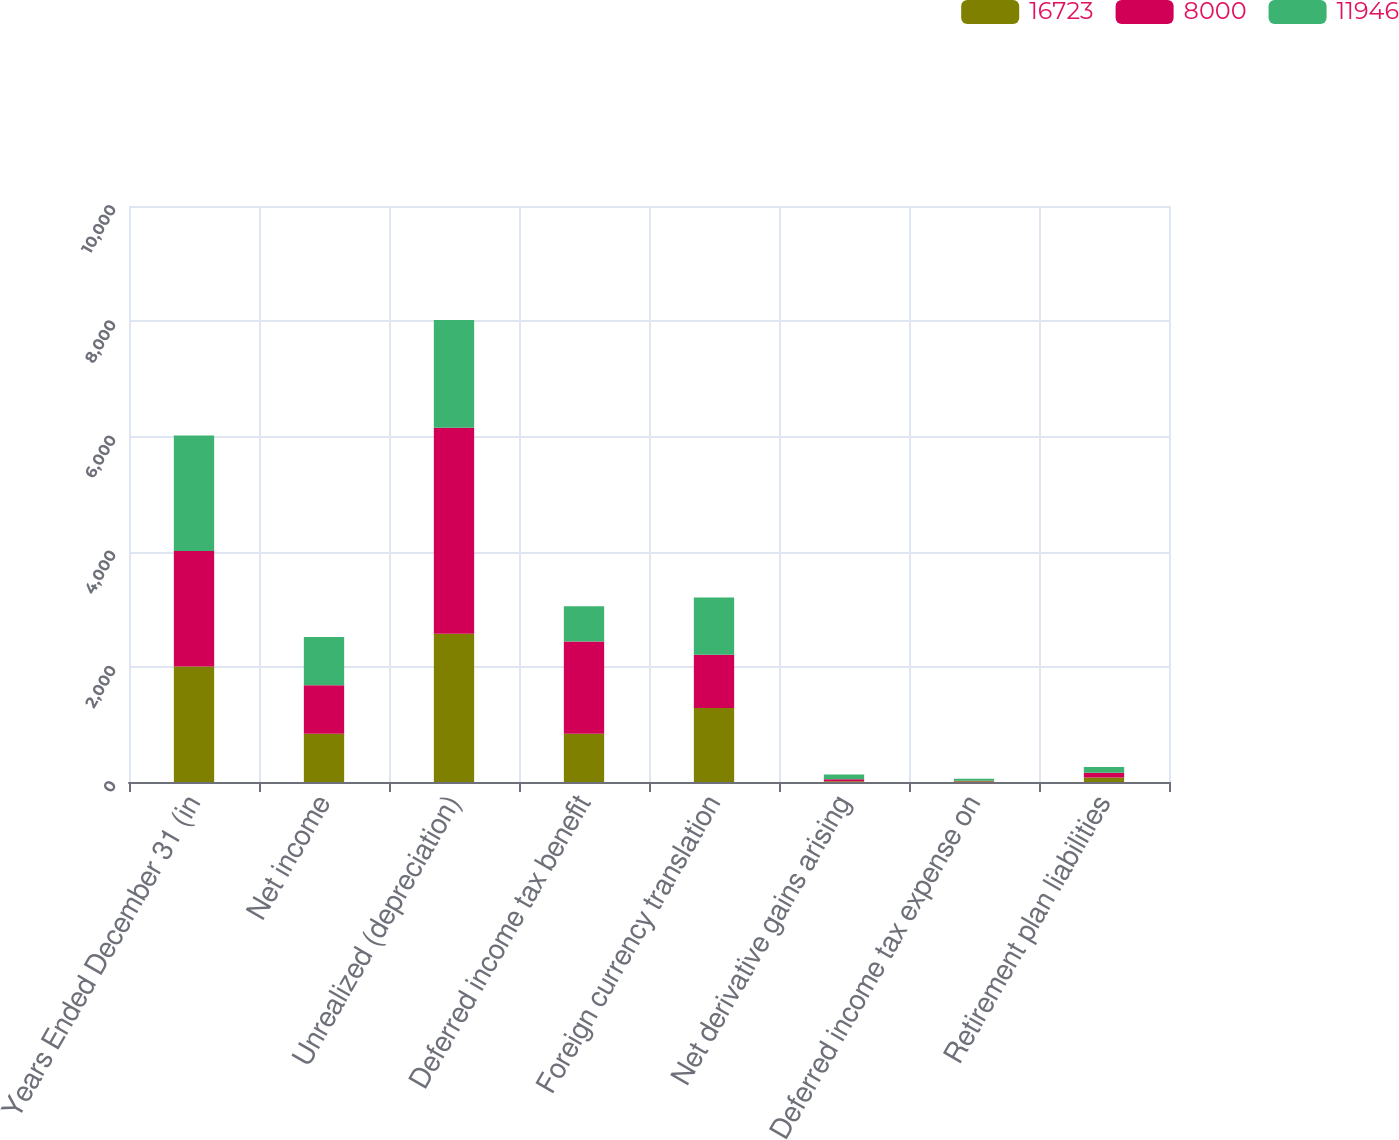<chart> <loc_0><loc_0><loc_500><loc_500><stacked_bar_chart><ecel><fcel>Years Ended December 31 (in<fcel>Net income<fcel>Unrealized (depreciation)<fcel>Deferred income tax benefit<fcel>Foreign currency translation<fcel>Net derivative gains arising<fcel>Deferred income tax expense on<fcel>Retirement plan liabilities<nl><fcel>16723<fcel>2006<fcel>839<fcel>2574<fcel>839<fcel>1283<fcel>13<fcel>15<fcel>80<nl><fcel>8000<fcel>2005<fcel>839<fcel>3577<fcel>1599<fcel>926<fcel>35<fcel>7<fcel>81<nl><fcel>11946<fcel>2004<fcel>839<fcel>1868<fcel>612<fcel>993<fcel>83<fcel>33<fcel>100<nl></chart> 